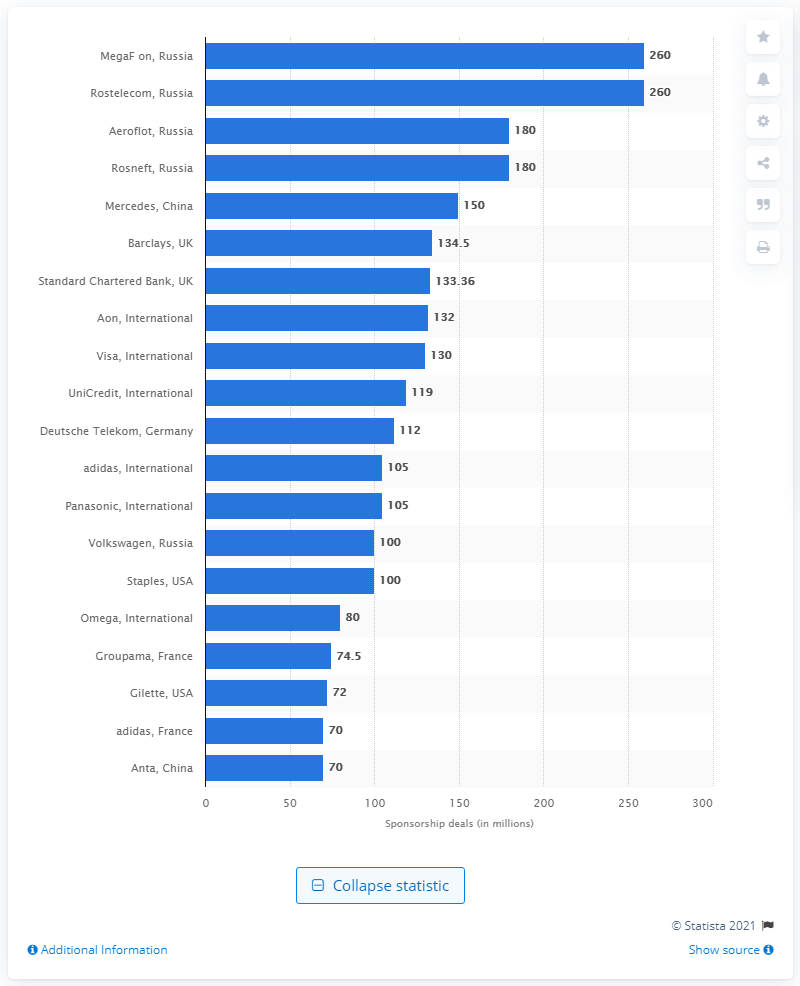Give some essential details in this illustration. The sponsorship of FC Bayern M14nchen was worth 112.. 